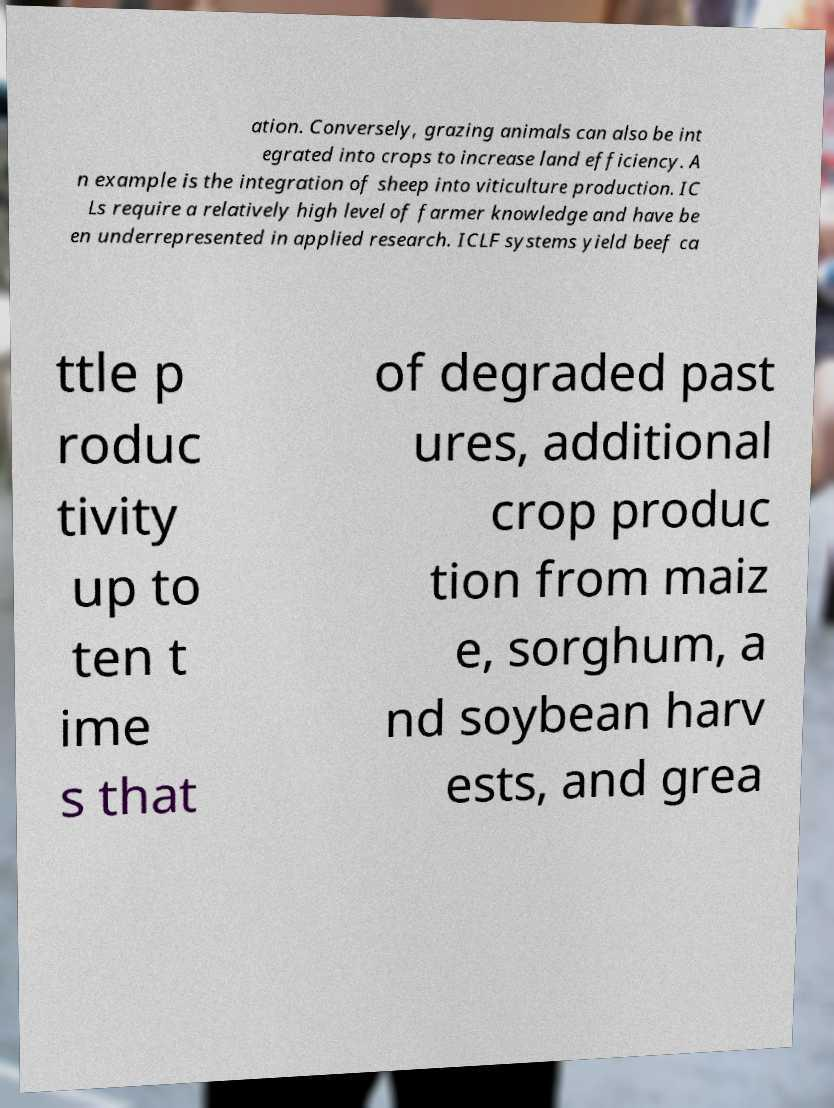Please read and relay the text visible in this image. What does it say? ation. Conversely, grazing animals can also be int egrated into crops to increase land efficiency. A n example is the integration of sheep into viticulture production. IC Ls require a relatively high level of farmer knowledge and have be en underrepresented in applied research. ICLF systems yield beef ca ttle p roduc tivity up to ten t ime s that of degraded past ures, additional crop produc tion from maiz e, sorghum, a nd soybean harv ests, and grea 